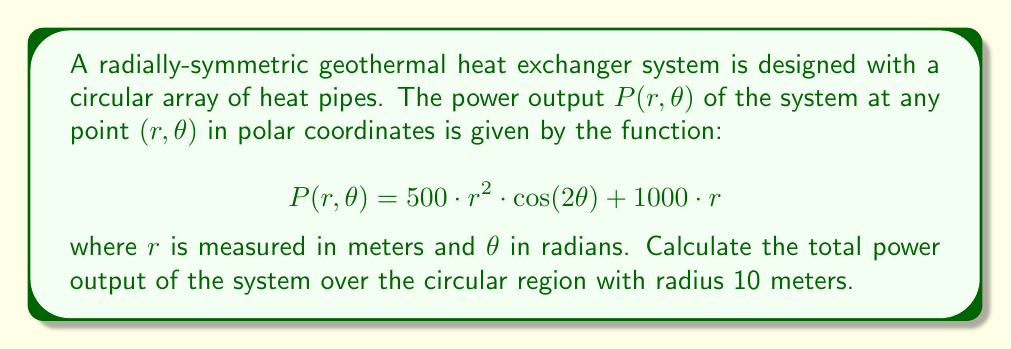What is the answer to this math problem? To solve this problem, we need to integrate the power output function over the given circular region. In polar coordinates, this involves a double integral:

$$\text{Total Power} = \int_0^{2\pi} \int_0^{10} P(r,\theta) \, r \, dr \, d\theta$$

Let's break this down step-by-step:

1) First, we substitute the given function into the integral:

   $$\int_0^{2\pi} \int_0^{10} (500 \cdot r^2 \cdot \cos(2\theta) + 1000 \cdot r) \, r \, dr \, d\theta$$

2) We can separate this into two integrals:

   $$\int_0^{2\pi} \int_0^{10} 500 \cdot r^3 \cdot \cos(2\theta) \, dr \, d\theta + \int_0^{2\pi} \int_0^{10} 1000 \cdot r^2 \, dr \, d\theta$$

3) Let's solve the first integral:
   
   $$500 \int_0^{2\pi} \cos(2\theta) \, d\theta \cdot \int_0^{10} r^3 \, dr$$
   
   The inner integral: $\int_0^{10} r^3 \, dr = [\frac{r^4}{4}]_0^{10} = 2500$
   
   The outer integral: $\int_0^{2\pi} \cos(2\theta) \, d\theta = 0$

   So, the first integral equals 0.

4) Now, let's solve the second integral:

   $$1000 \cdot 2\pi \cdot \int_0^{10} r^2 \, dr = 1000 \cdot 2\pi \cdot [\frac{r^3}{3}]_0^{10} = 1000 \cdot 2\pi \cdot \frac{1000}{3} = \frac{2000000\pi}{3}$$

5) The total power is the sum of these two integrals:

   $$\text{Total Power} = 0 + \frac{2000000\pi}{3} = \frac{2000000\pi}{3} \text{ watts}$$
Answer: The total power output of the geothermal heat exchanger system over the circular region with radius 10 meters is $\frac{2000000\pi}{3}$ watts, or approximately 2,094,395 watts. 